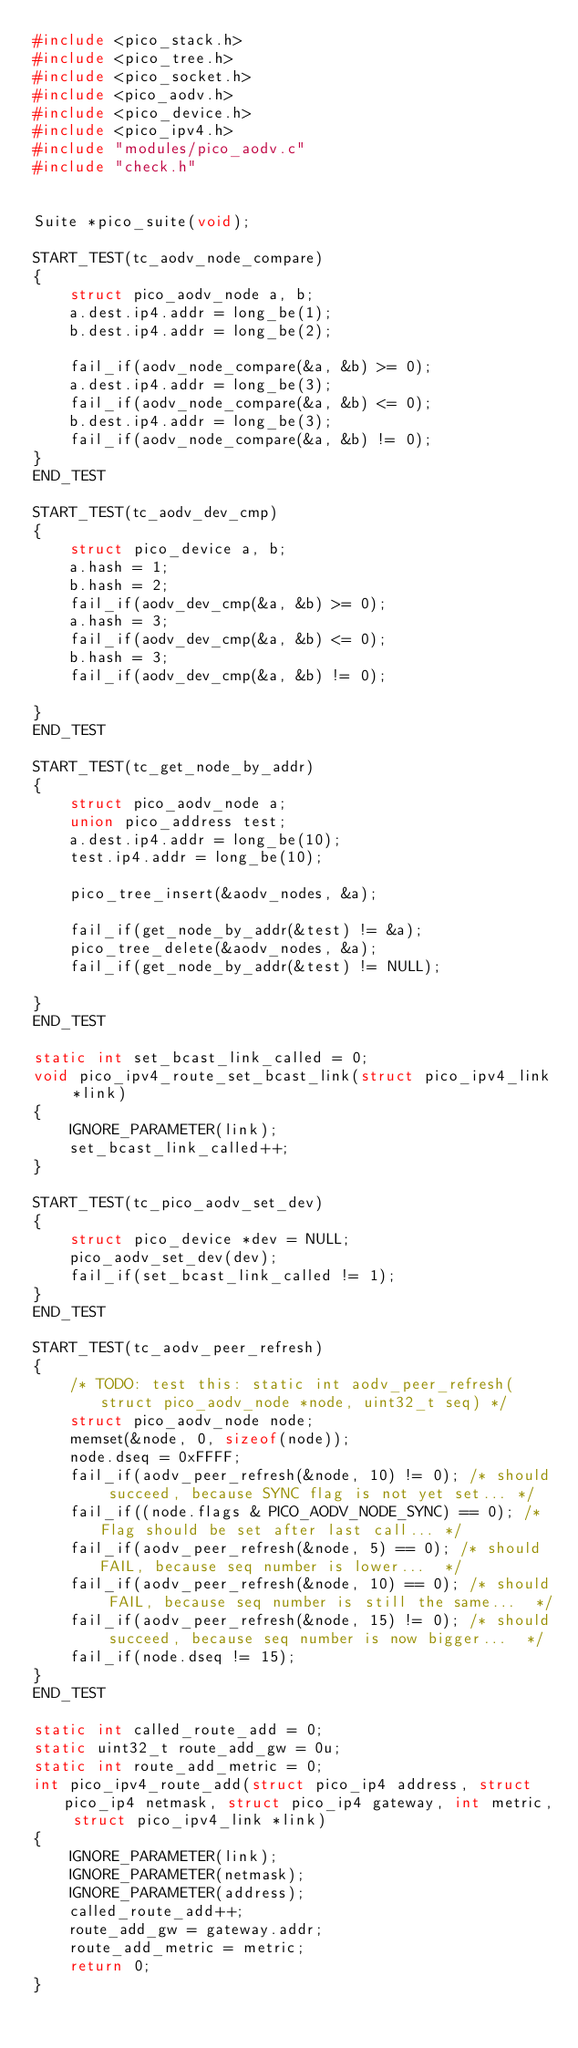<code> <loc_0><loc_0><loc_500><loc_500><_C_>#include <pico_stack.h>
#include <pico_tree.h>
#include <pico_socket.h>
#include <pico_aodv.h>
#include <pico_device.h>
#include <pico_ipv4.h>
#include "modules/pico_aodv.c"
#include "check.h"


Suite *pico_suite(void);

START_TEST(tc_aodv_node_compare)
{
    struct pico_aodv_node a, b;
    a.dest.ip4.addr = long_be(1);
    b.dest.ip4.addr = long_be(2);

    fail_if(aodv_node_compare(&a, &b) >= 0);
    a.dest.ip4.addr = long_be(3);
    fail_if(aodv_node_compare(&a, &b) <= 0);
    b.dest.ip4.addr = long_be(3);
    fail_if(aodv_node_compare(&a, &b) != 0);
}
END_TEST

START_TEST(tc_aodv_dev_cmp)
{
    struct pico_device a, b;
    a.hash = 1;
    b.hash = 2;
    fail_if(aodv_dev_cmp(&a, &b) >= 0);
    a.hash = 3;
    fail_if(aodv_dev_cmp(&a, &b) <= 0);
    b.hash = 3;
    fail_if(aodv_dev_cmp(&a, &b) != 0);

}
END_TEST

START_TEST(tc_get_node_by_addr)
{
    struct pico_aodv_node a;
    union pico_address test;
    a.dest.ip4.addr = long_be(10);
    test.ip4.addr = long_be(10);

    pico_tree_insert(&aodv_nodes, &a);

    fail_if(get_node_by_addr(&test) != &a);
    pico_tree_delete(&aodv_nodes, &a);
    fail_if(get_node_by_addr(&test) != NULL);

}
END_TEST

static int set_bcast_link_called = 0;
void pico_ipv4_route_set_bcast_link(struct pico_ipv4_link *link)
{
    IGNORE_PARAMETER(link);
    set_bcast_link_called++;
}

START_TEST(tc_pico_aodv_set_dev)
{
    struct pico_device *dev = NULL;
    pico_aodv_set_dev(dev);
    fail_if(set_bcast_link_called != 1);
}
END_TEST

START_TEST(tc_aodv_peer_refresh)
{
    /* TODO: test this: static int aodv_peer_refresh(struct pico_aodv_node *node, uint32_t seq) */
    struct pico_aodv_node node;
    memset(&node, 0, sizeof(node));
    node.dseq = 0xFFFF;
    fail_if(aodv_peer_refresh(&node, 10) != 0); /* should succeed, because SYNC flag is not yet set... */
    fail_if((node.flags & PICO_AODV_NODE_SYNC) == 0); /* Flag should be set after last call... */
    fail_if(aodv_peer_refresh(&node, 5) == 0); /* should FAIL, because seq number is lower...  */
    fail_if(aodv_peer_refresh(&node, 10) == 0); /* should FAIL, because seq number is still the same...  */
    fail_if(aodv_peer_refresh(&node, 15) != 0); /* should succeed, because seq number is now bigger...  */
    fail_if(node.dseq != 15);
}
END_TEST

static int called_route_add = 0;
static uint32_t route_add_gw = 0u;
static int route_add_metric = 0;
int pico_ipv4_route_add(struct pico_ip4 address, struct pico_ip4 netmask, struct pico_ip4 gateway, int metric, struct pico_ipv4_link *link)
{
    IGNORE_PARAMETER(link);
    IGNORE_PARAMETER(netmask);
    IGNORE_PARAMETER(address);
    called_route_add++;
    route_add_gw = gateway.addr;
    route_add_metric = metric;
    return 0;
}
</code> 